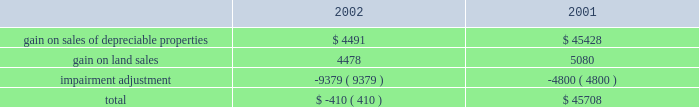Management 2019s discussion and analysis of financial conditionand results of operations d u k e r e a l t y c o r p o r a t i o n 1 1 2 0 0 2 a n n u a l r e p o r t 2022 interest expense on the company 2019s secured debt decreased from $ 30.8 million in 2001 to $ 22.9 million in 2002 as the company paid off $ 13.5 million of secured debt throughout 2002 and experienced lower borrowings on its secured line of credit during 2002 compared to 2001 .
Additionally , the company paid off approximately $ 128.5 million of secured debt throughout 2001 .
2022 interest expense on the company 2019s $ 500 million unsecured line of credit decreased by approximately $ 1.1 million in 2002 compared to 2001 as the company maintained lower balances on the line throughout most of 2002 .
As a result of the above-mentioned items , earnings from rental operations decreased $ 35.0 million from $ 254.1 million for the year ended december 31 , 2001 , to $ 219.1 million for the year ended december 31 , 2002 .
Service operations service operations primarily consist of leasing , management , construction and development services for joint venture properties and properties owned by third parties .
Service operations revenues decreased from $ 80.5 million for the year ended december 31 , 2001 , to $ 68.6 million for the year ended december 31 , 2002 .
The prolonged effect of the slow economy has been the primary factor in the overall decrease in revenues .
The company experienced a decrease of $ 12.7 million in net general contractor revenues because of a decrease in the volume of construction in 2002 , compared to 2001 , as well as slightly lower profit margins .
Property management , maintenance and leasing fee revenues decreased from $ 22.8 million in 2001 to $ 14.3 million in 2002 primarily because of a decrease in landscaping maintenance revenue resulting from the sale of the landscaping operations in the third quarter of 2001 .
Construction management and development activity income represents construction and development fees earned on projects where the company acts as the construction manager along with profits from the company 2019s held for sale program whereby the company develops a property for sale upon completion .
The increase in revenues of $ 10.3 million in 2002 is primarily due to an increase in volume of the sale of properties from the held for sale program .
Service operations expenses decreased from $ 45.3 million in 2001 to $ 38.3 million in 2002 .
The decrease is attributable to the decrease in construction and development activity and the reduced overhead costs as a result of the sale of the landscape business in 2001 .
As a result of the above , earnings from service operations decreased from $ 35.1 million for the year ended december 31 , 2001 , to $ 30.3 million for the year ended december 31 , 2002 .
General and administrative expense general and administrative expense increased from $ 15.6 million in 2001 to $ 25.4 million for the year ended december 31 , 2002 .
The company has been successful reducing total operating and administration costs ; however , reduced construction and development activities have resulted in a greater amount of overhead being charged to general and administrative expense instead of being capitalized into development projects or charged to service operations .
Other income and expenses gain on sale of land and depreciable property dispositions , net of impairment adjustment , is comprised of the following amounts in 2002 and 2001 : gain on sales of depreciable properties represent sales of previously held for investment rental properties .
Beginning in 2000 and continuing into 2001 , the company pursued favorable opportunities to dispose of real estate assets that no longer met long-term investment objectives .
In 2002 , the company significantly reduced this property sales program until the business climate improves and provides better investment opportunities for the sale proceeds .
Gain on land sales represents sales of undeveloped land owned by the company .
The company pursues opportunities to dispose of land in markets with a high concentration of undeveloped land and those markets where the land no longer meets strategic development plans of the company .
The company recorded a $ 9.4 million adjustment in 2002 associated with six properties determined to have an impairment of book value .
The company has analyzed each of its in-service properties and has determined that there are no additional valuation adjustments that need to be made as of december 31 , 2002 .
The company recorded an adjustment of $ 4.8 million in 2001 for one property that the company had contracted to sell for a price less than its book value .
Other revenue for the year ended december 31 , 2002 , includes $ 1.4 million of gain related to an interest rate swap that did not qualify for hedge accounting. .

What was the ratio of the impairment adjustment in 2001 compared to 2002? 
Computations: (9379 / 4800)
Answer: 1.95396. 